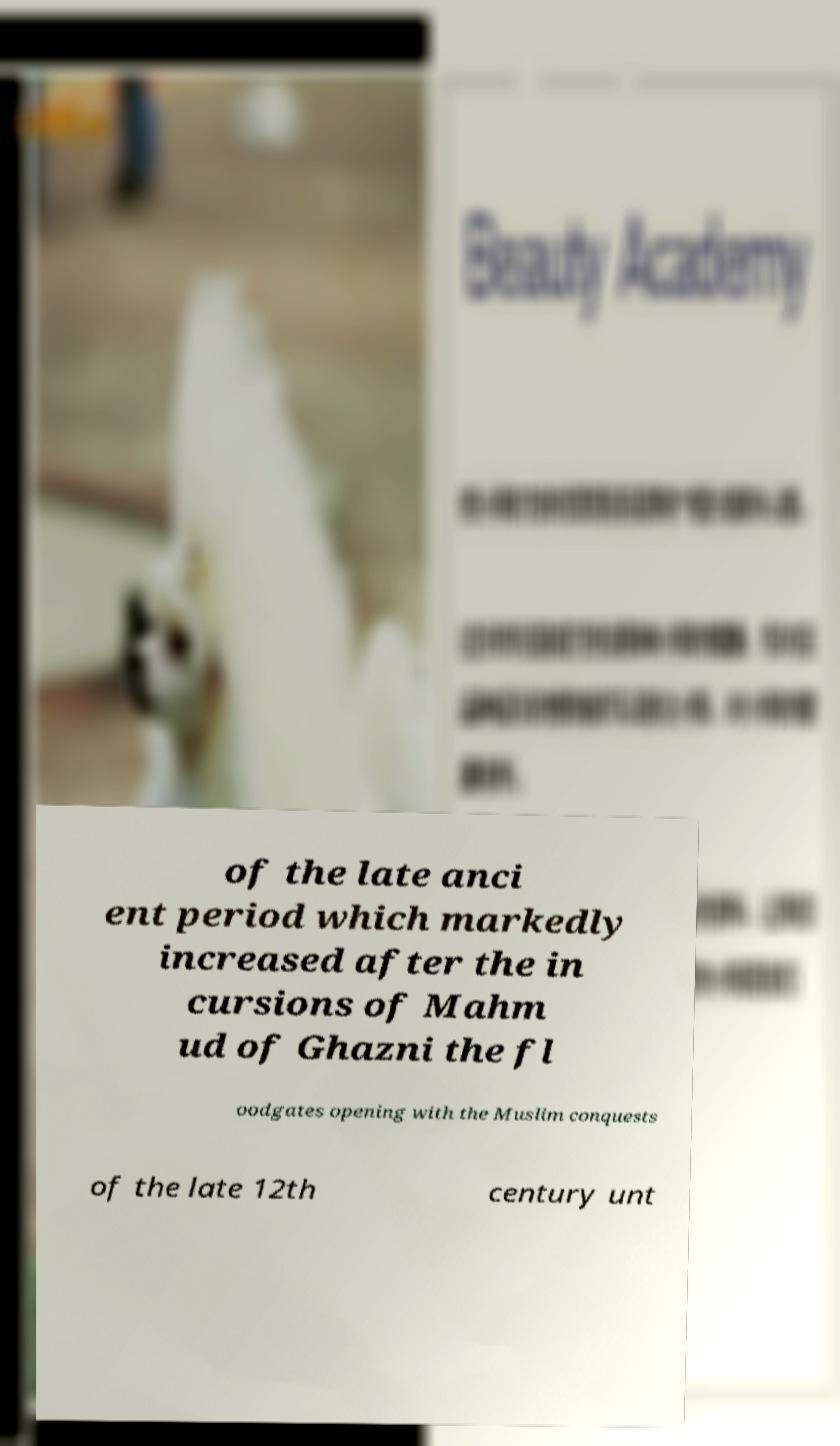Please identify and transcribe the text found in this image. of the late anci ent period which markedly increased after the in cursions of Mahm ud of Ghazni the fl oodgates opening with the Muslim conquests of the late 12th century unt 